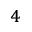Convert formula to latex. <formula><loc_0><loc_0><loc_500><loc_500>_ { 4 }</formula> 